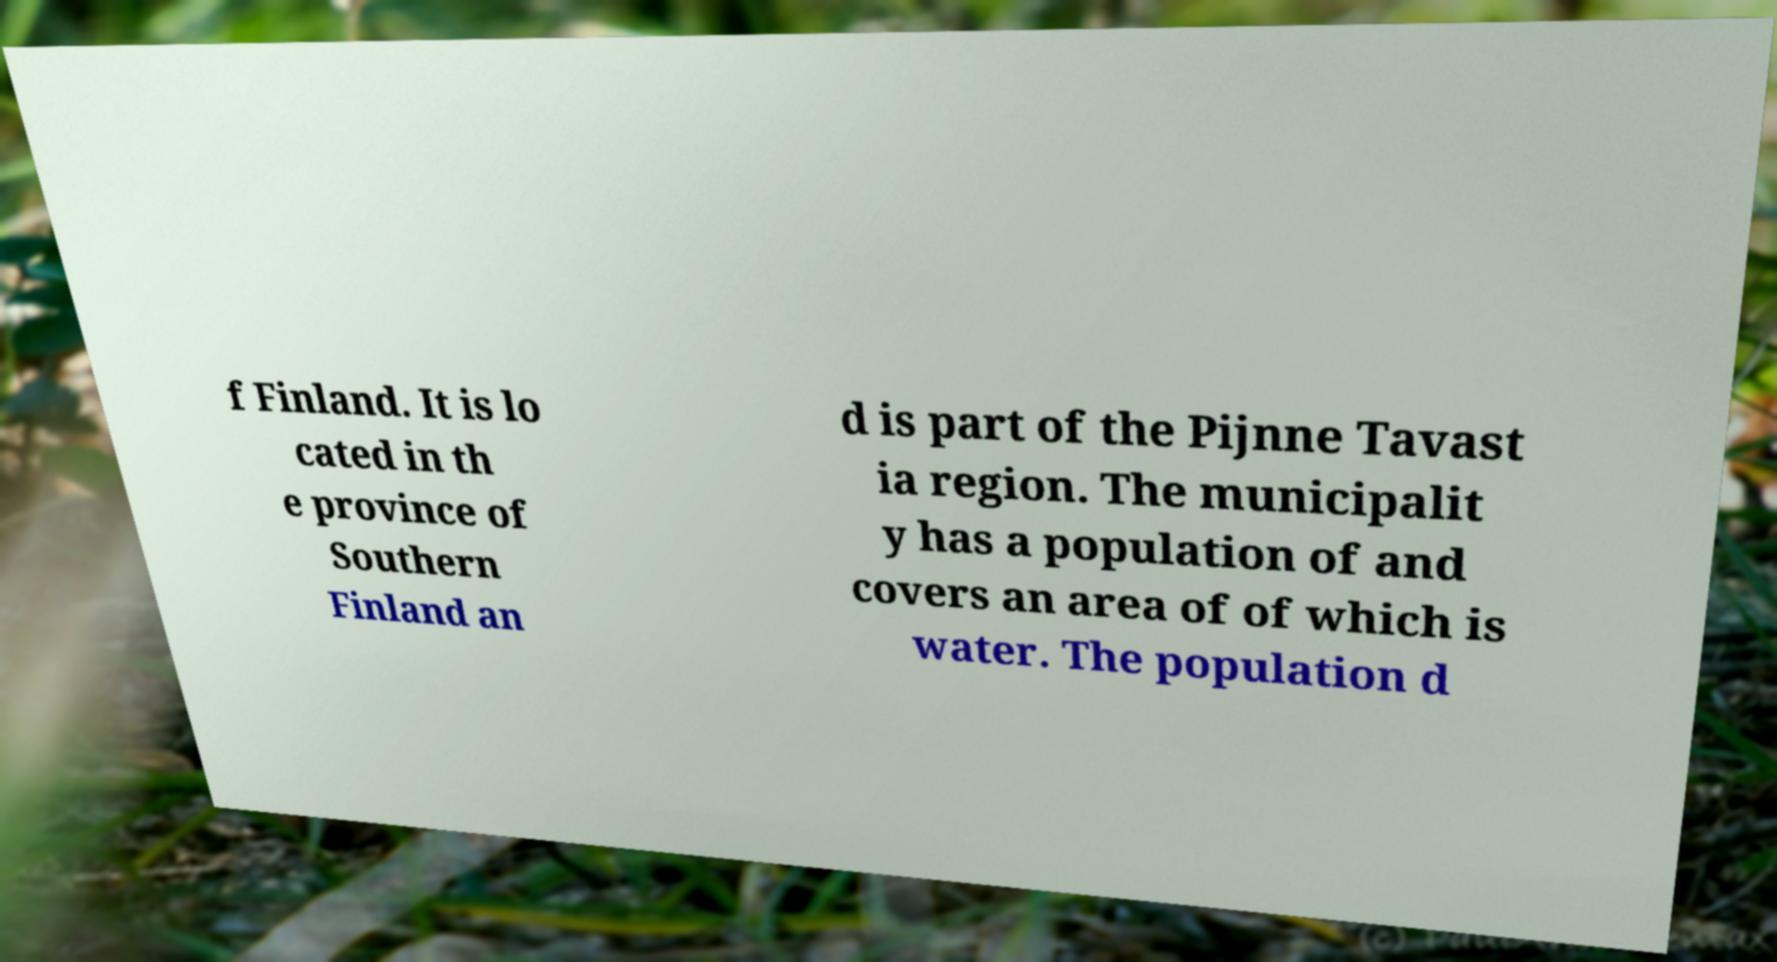Can you read and provide the text displayed in the image?This photo seems to have some interesting text. Can you extract and type it out for me? f Finland. It is lo cated in th e province of Southern Finland an d is part of the Pijnne Tavast ia region. The municipalit y has a population of and covers an area of of which is water. The population d 